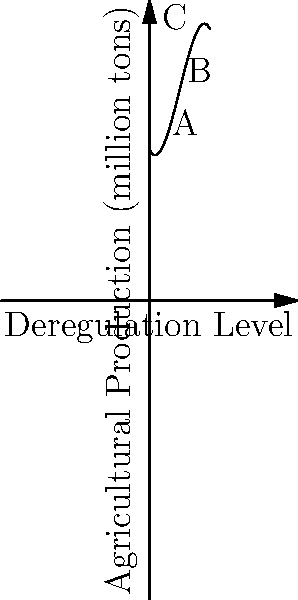The graph represents the relationship between deregulation levels and agricultural production. Which point on the curve represents the optimal balance between deregulation and production, and why might this be significant for agricultural policy? To determine the optimal balance, we need to analyze the curve:

1. The curve represents agricultural production as a function of deregulation level.
2. Point A (1,f(1)) shows low deregulation with moderate production.
3. Point B (2,f(2)) is at the peak of the curve, indicating maximum production.
4. Point C (3,f(3)) shows high deregulation but decreased production.

The optimal balance is at point B because:
1. It represents the highest point on the curve, maximizing agricultural production.
2. It suggests that moderate deregulation leads to the best outcomes.
3. Beyond this point, further deregulation (moving to C) actually reduces production.

This is significant for agricultural policy because:
1. It supports a balanced approach to deregulation.
2. It suggests that extreme policies (either too much regulation or too much deregulation) may be counterproductive.
3. It provides a data-driven basis for setting deregulation levels to optimize agricultural output.
Answer: Point B, representing moderate deregulation for maximum production. 